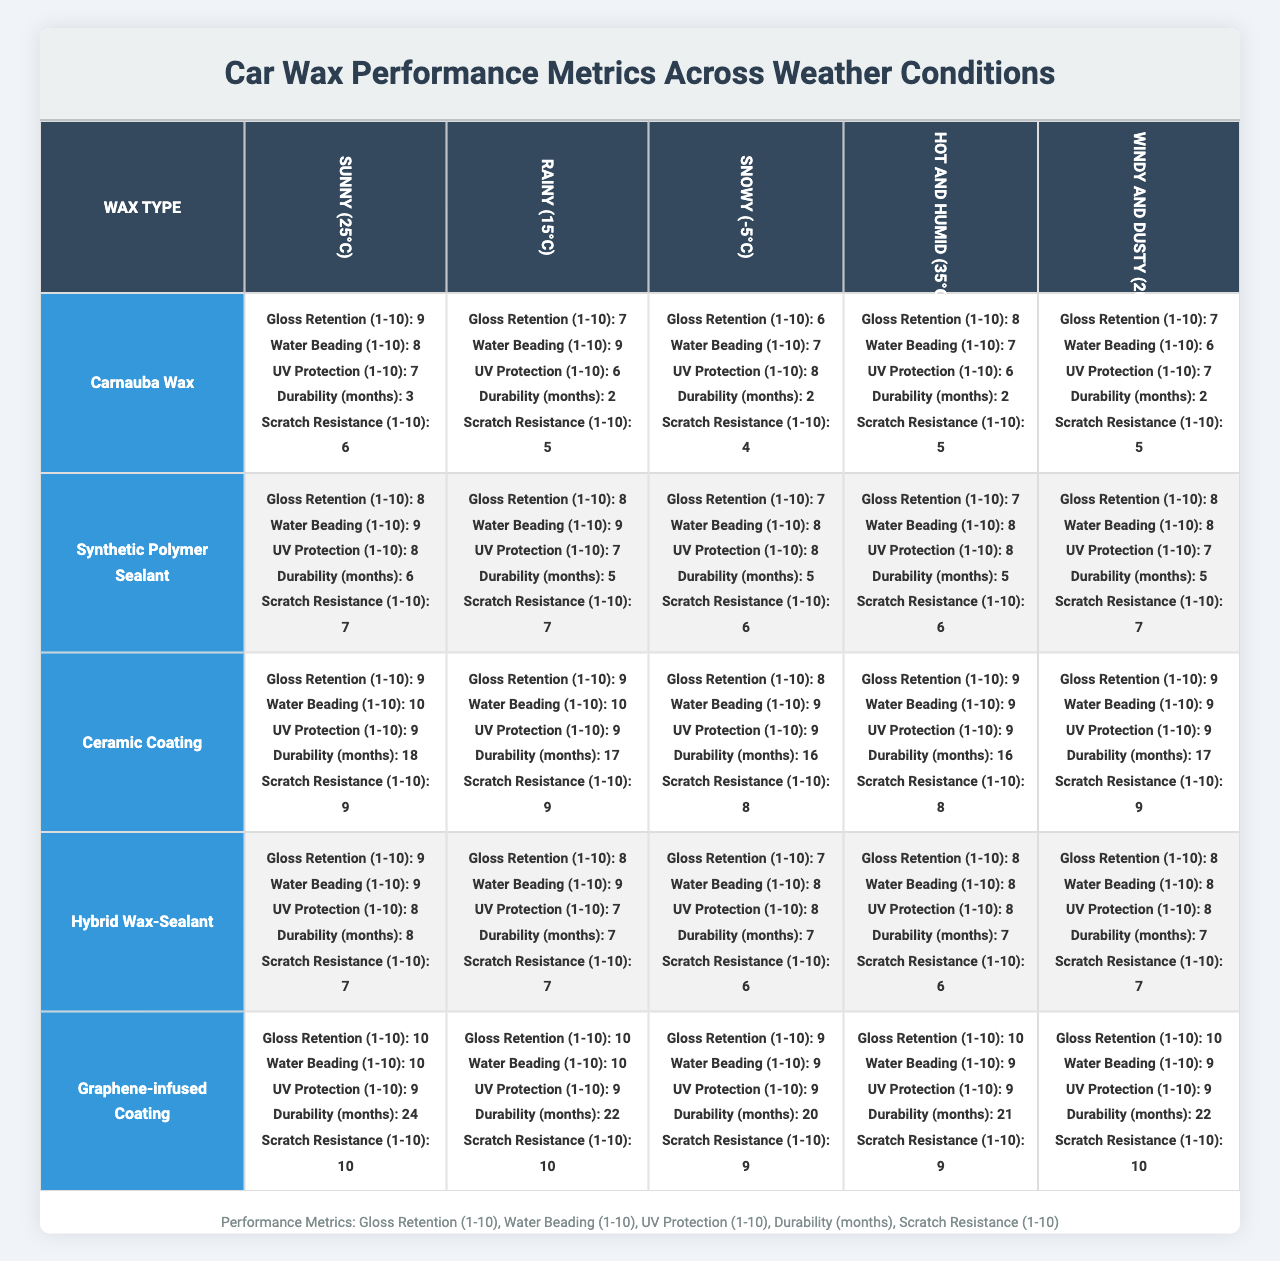What is the Gloss Retention score for Graphene-infused Coating in Sunny (25°C) conditions? The table shows that for the Graphene-infused Coating in Sunny (25°C) conditions, the Gloss Retention score is 10.
Answer: 10 What was the Water Beading score for Carnauba Wax in Rainy (15°C)? In the Rainy (15°C) condition, the Water Beading score for Carnauba Wax is 9.
Answer: 9 Which wax type scores the highest in Scratch Resistance during Hot and Humid (35°C) conditions? The Scratch Resistance score during Hot and Humid (35°C) for each wax type is compared, and the Graphene-infused Coating has the highest score of 9.
Answer: Graphene-infused Coating What is the average durability of all wax types in Snowy (-5°C)? The durability in months for each wax type in Snowy (-5°C) is [2, 5, 16, 7, 20]. The average is calculated as (2 + 5 + 16 + 7 + 20) / 5 = 10.
Answer: 10 Is the UV Protection score for Ceramic Coating consistent across all weather conditions? By reviewing the UV Protection values for Ceramic Coating across weather conditions: 9, 9, 9, 9, 9, they are all the same. Hence, it is consistent.
Answer: Yes What is the best overall performance (sum of all metrics) of Synthetic Polymer Sealant across all weather conditions? The scores for Synthetic Polymer Sealant across all conditions are totaled: (8+9+8+6+7) + (8+9+7+5+7) + (7+8+8+5+6) + (7+8+8+5+6) + (8+8+7+5+7) = 83.
Answer: 83 What weather condition showed the poorest Scratch Resistance for Hybrid Wax-Sealant? The Scratch Resistance scores for Hybrid Wax-Sealant reveal: [7, 7, 6, 6, 7]. The lowest score is 6, which occurs in Snowy (-5°C).
Answer: Snowy (-5°C) Which wax type exhibits the best overall durability and in which condition? The durability scores show: Carnauba Wax: 3, Synthetic Polymer Sealant: 6, Ceramic Coating: 18, Hybrid Wax-Sealant: 8, Graphene-infused Coating: 24. The best is Graphene-infused Coating with a score of 24 in Sunny (25°C).
Answer: Graphene-infused Coating, Sunny (25°C) What is the difference in Water Beading scores between Carnauba Wax and Graphene-infused Coating in Windy and Dusty (20°C)? The Water Beading scores are 6 for Carnauba Wax and 9 for Graphene-infused Coating. The difference is calculated as 9 - 6 = 3.
Answer: 3 Which wax type has the lowest Gloss Retention in Rainy (15°C) conditions? By examining the Gloss Retention scores in Rainy (15°C): Carnauba Wax (7), Synthetic Polymer Sealant (8), Ceramic Coating (9), Hybrid Wax-Sealant (8), and Graphene-infused Coating (10), Carnauba Wax has the lowest at 7.
Answer: Carnauba Wax 